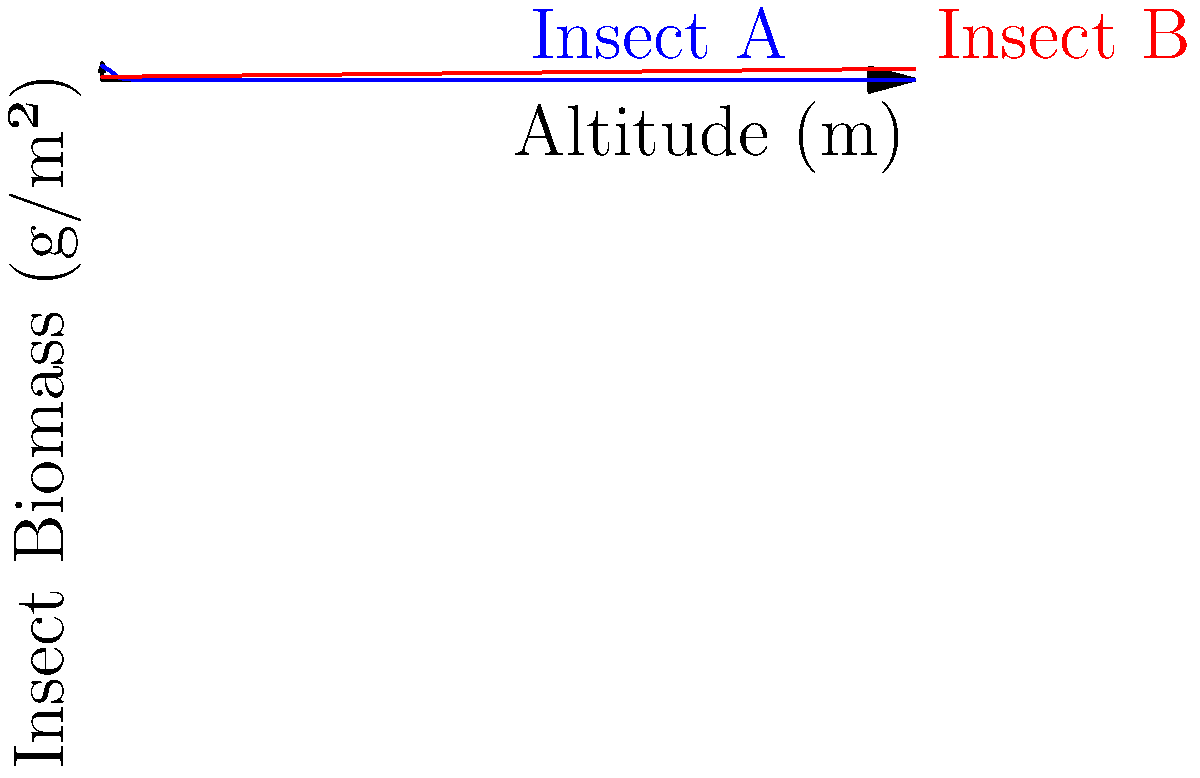The graph shows the biomass distribution of two insect species along an altitude gradient. Insect A's biomass (in g/m²) is given by $f(x) = 50e^{-0.0005x^2}$, and Insect B's biomass is given by $g(x) = 10 + 0.01x$, where $x$ is the altitude in meters. Calculate the difference in total biomass between Insect A and Insect B from sea level to 3000m altitude. To solve this problem, we need to integrate both functions over the given range and then find the difference. Let's break it down step-by-step:

1) For Insect A:
   $$\int_0^{3000} 50e^{-0.0005x^2} dx$$
   This integral doesn't have a simple analytical solution, so we'll need to use numerical integration methods.

2) For Insect B:
   $$\int_0^{3000} (10 + 0.01x) dx$$
   We can solve this analytically:
   $$[10x + 0.005x^2]_0^{3000}$$
   $$= (30000 + 45000) - (0 + 0) = 75000$$

3) Using a numerical integration method (like Simpson's rule or a computer algebra system) for Insect A's integral, we get approximately 48,394.

4) The difference in total biomass:
   48,394 - 75,000 = -26,606 g/m

Therefore, Insect B has a greater total biomass over the altitude range, exceeding Insect A's by about 26,606 g/m.
Answer: -26,606 g/m 